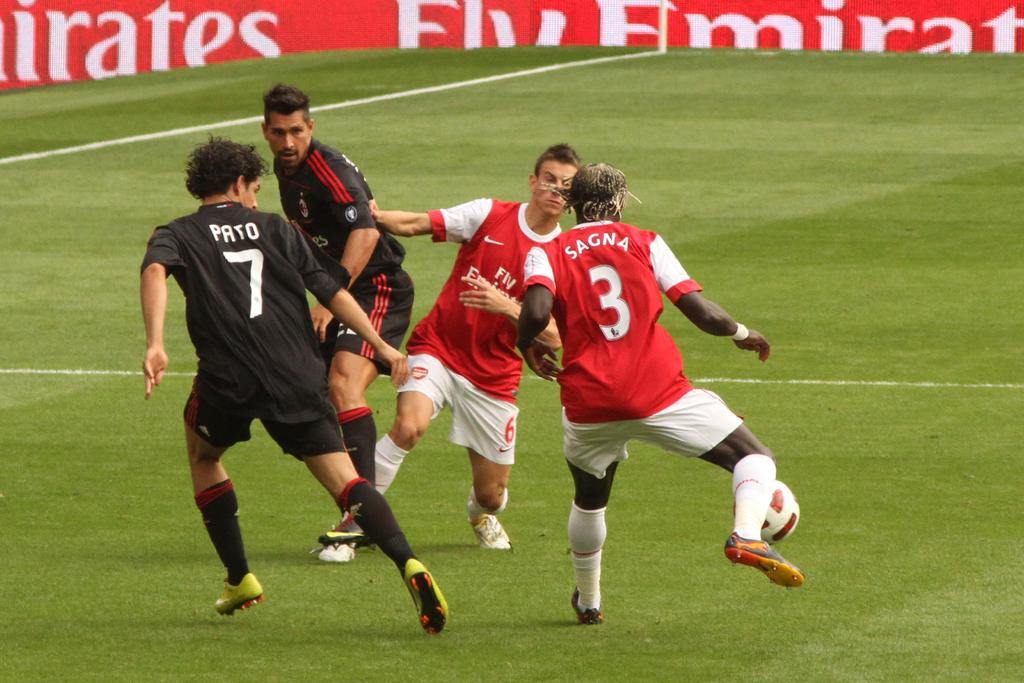How many men are present in the image? There are four men in the image. What are the men wearing? Two of the men are wearing red and black T-shirts. What activity are the men engaged in? The men are running on the ground. What are they running for? They are running for a ball. What can be seen in the background of the image? There is a banner visible in the background of the image. Can you tell me which vein is most prominent on the men's faces in the image? There is no mention of veins or faces in the provided facts, so it is not possible to answer this question. --- Facts: 1. There is a car in the image. 2. The car is parked on the street. 3. The car is red. 4. There are trees on the street. 5. The street is paved. Absurd Topics: parrot, sand, ocean Conversation: What is the main subject of the image? The main subject of the image is a car. Where is the car located? The car is parked on the street. What color is the car? The car is red. What can be seen on the street besides the car? There are trees on the street. How is the street surface? The street is paved. Reasoning: Let's think step by step in order to produce the conversation. We start by identifying the main subject of the image, which is the car. Then, we describe its location, noting that it is parked on the street. Next, we specify the color of the car, which is red. We then mention the presence of trees on the street. Finally, we describe the street surface, which is paved. Absurd Question/Answer: Can you tell me how many parrots are sitting on the car in the image? There is no mention of parrots in the provided facts, so it is not possible to answer this question. 